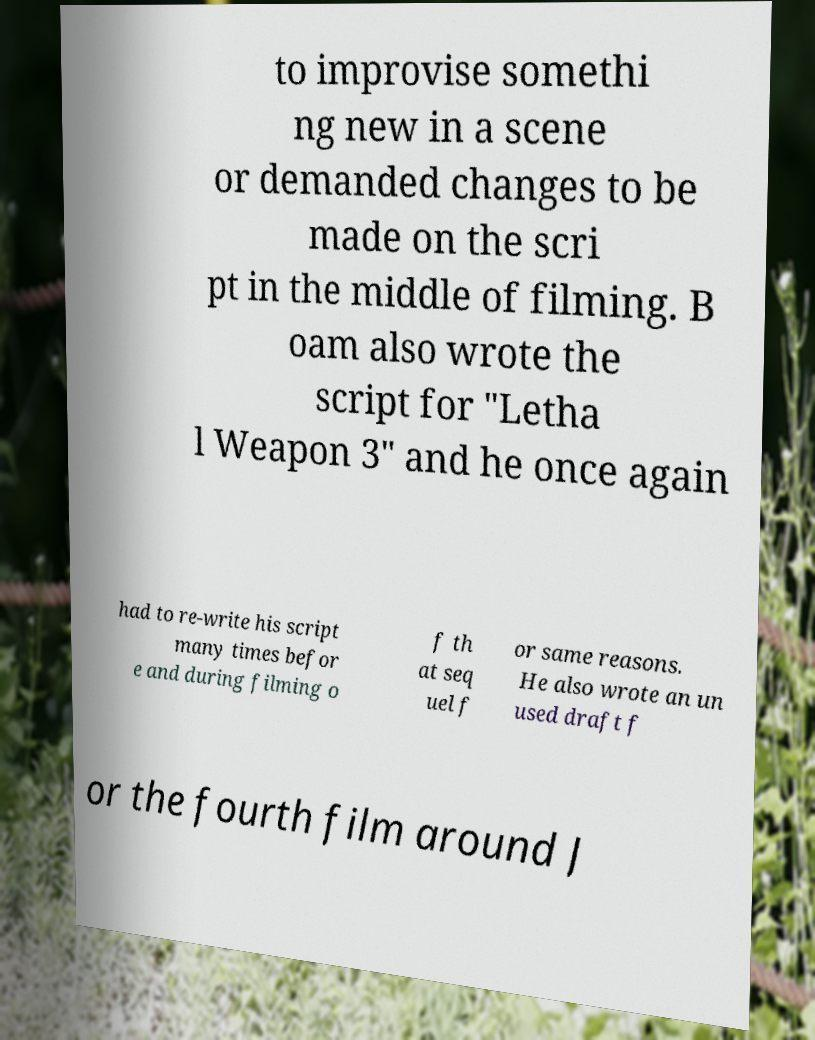For documentation purposes, I need the text within this image transcribed. Could you provide that? to improvise somethi ng new in a scene or demanded changes to be made on the scri pt in the middle of filming. B oam also wrote the script for "Letha l Weapon 3" and he once again had to re-write his script many times befor e and during filming o f th at seq uel f or same reasons. He also wrote an un used draft f or the fourth film around J 